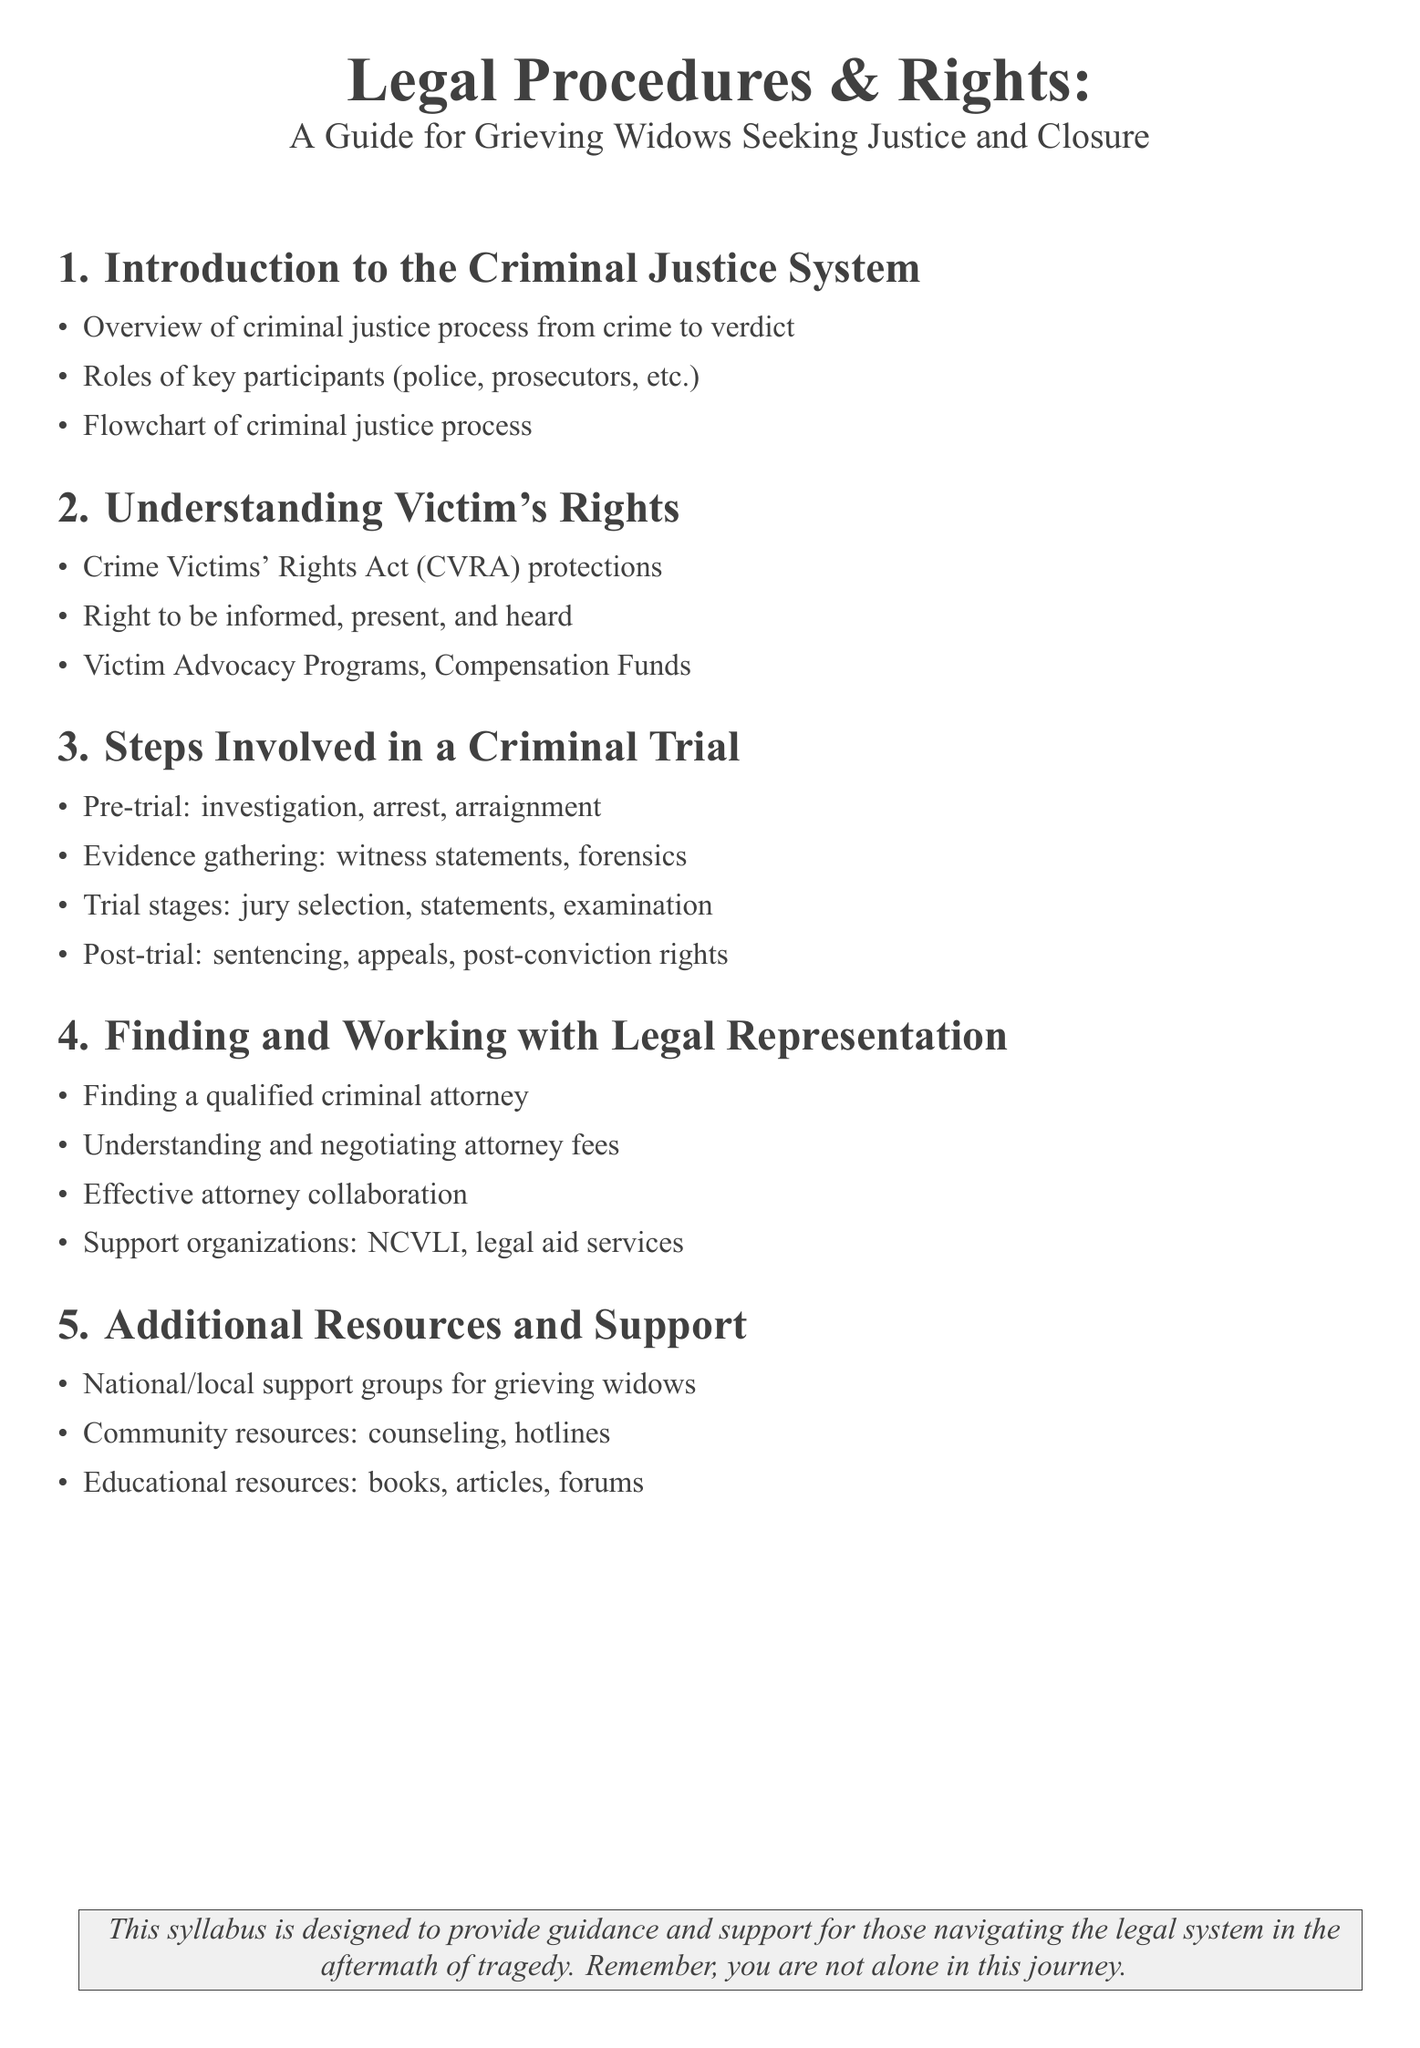What is the title of the syllabus? The title is the main heading that provides an overview of the content.
Answer: Legal Procedures & Rights: A Guide for Grieving Widows Seeking Justice and Closure How many sections are in the syllabus? The number of sections is indicated by the main points listed in the document.
Answer: 5 What does CVRA stand for? CVRA is an acronym mentioned under victim's rights in the document.
Answer: Crime Victims' Rights Act What is included in the steps involved in a criminal trial? The steps mentioned cover multiple stages that are typically followed in legal proceedings.
Answer: Pre-trial, Evidence gathering, Trial stages, Post-trial What is one organization listed for finding legal representation? The document provides support organizations that can assist in finding legal help.
Answer: NCVLI What does the syllabus say about support for grieving widows? This refers to the resources provided for individuals coping with loss mentioned in the document.
Answer: National/local support groups for grieving widows What is the purpose of this syllabus? The purpose is stated in the last section to highlight the overall intent of the document.
Answer: Guidance and support for those navigating the legal system What is mentioned as a community resource? The document lists additional resources available for support and assistance.
Answer: Counseling, hotlines What role do prosecutors play in the criminal justice process? This question relates to key participants described in the overview section of the syllabus.
Answer: Key participants 